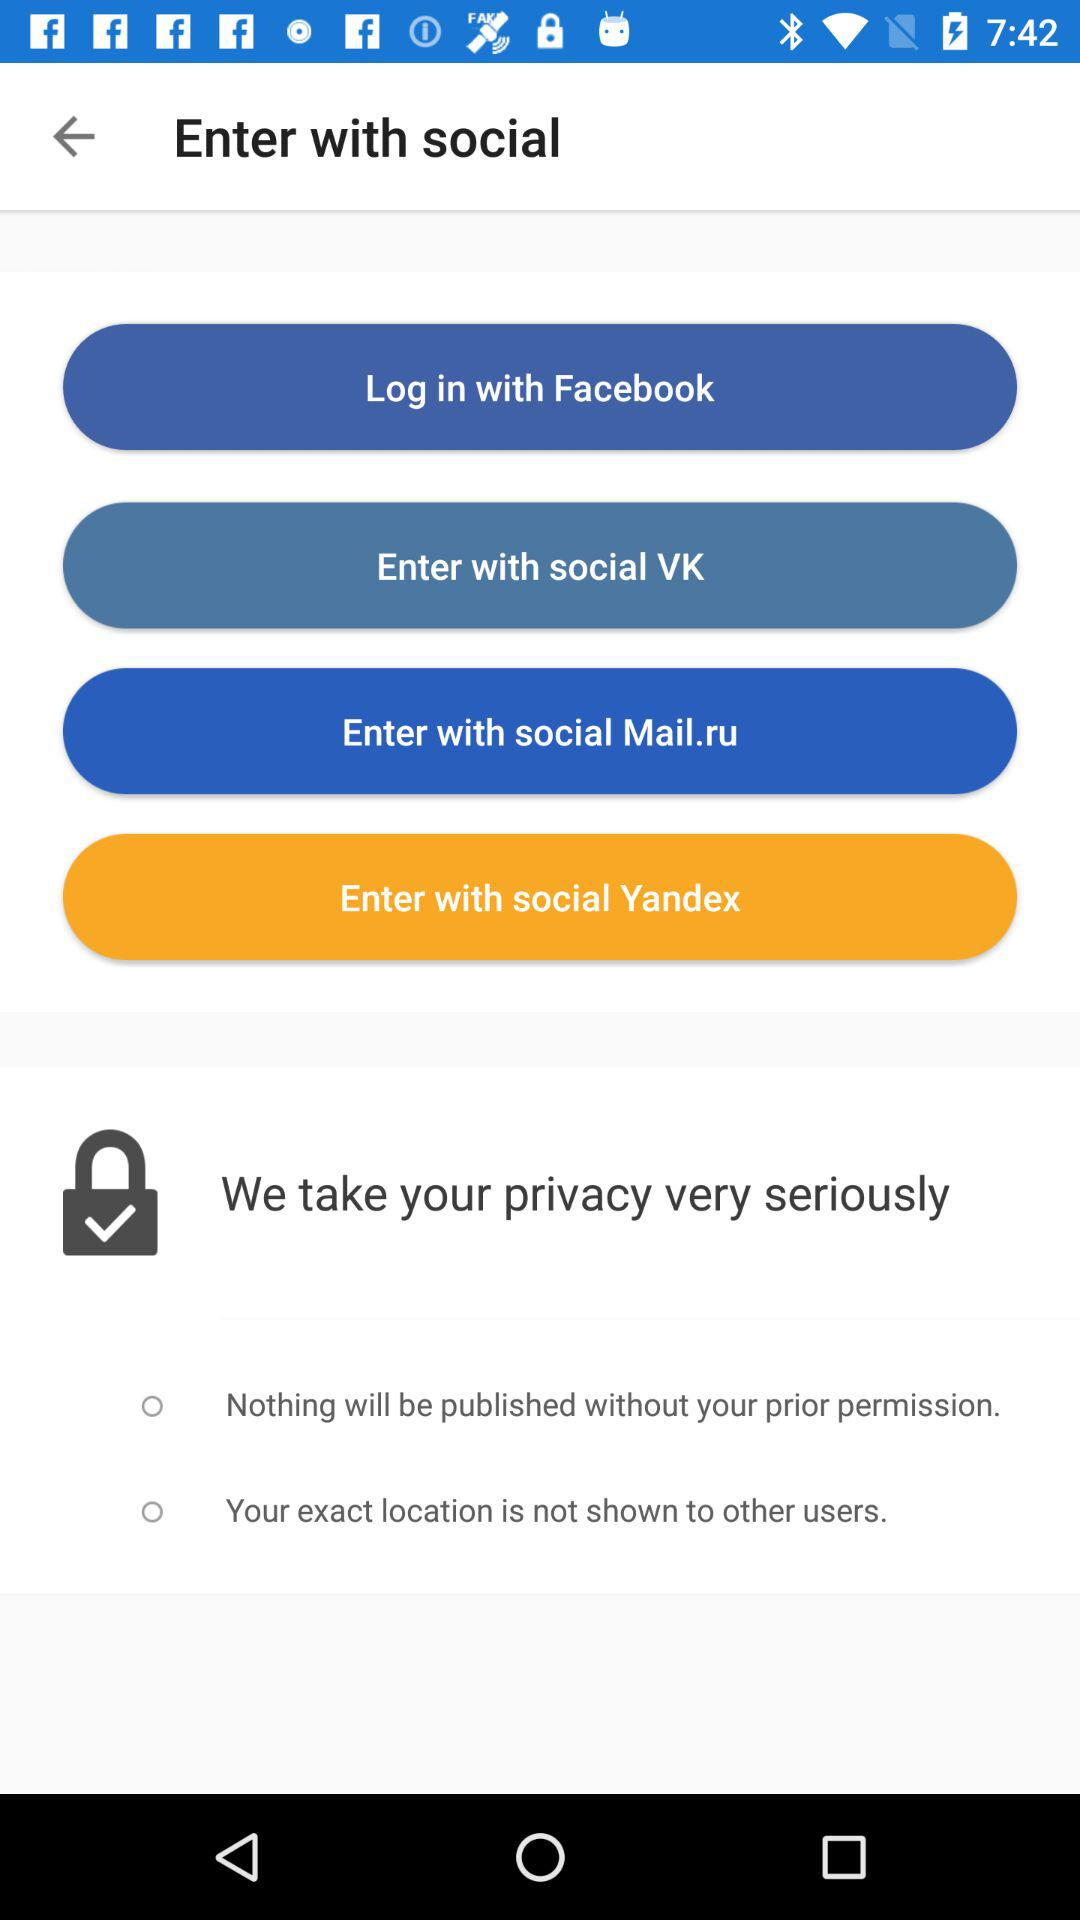How many privacy settings are available?
Answer the question using a single word or phrase. 2 